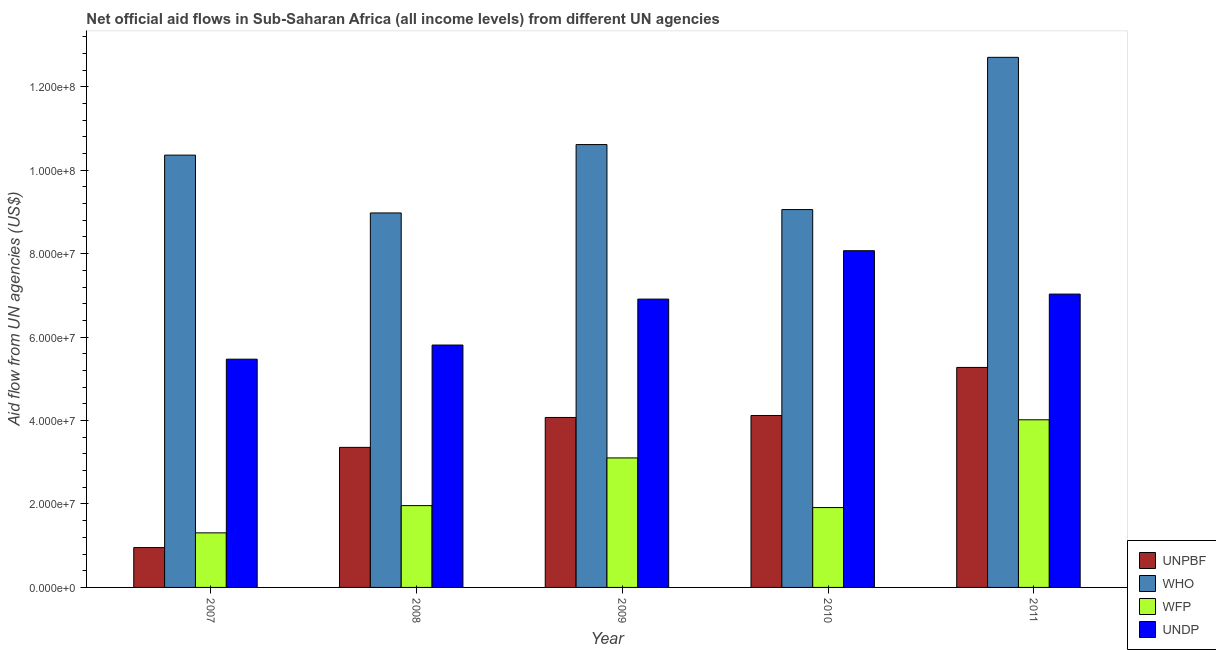How many bars are there on the 5th tick from the left?
Your answer should be compact. 4. How many bars are there on the 2nd tick from the right?
Give a very brief answer. 4. In how many cases, is the number of bars for a given year not equal to the number of legend labels?
Your answer should be compact. 0. What is the amount of aid given by wfp in 2008?
Your answer should be compact. 1.96e+07. Across all years, what is the maximum amount of aid given by wfp?
Provide a short and direct response. 4.02e+07. Across all years, what is the minimum amount of aid given by wfp?
Offer a terse response. 1.31e+07. In which year was the amount of aid given by who minimum?
Provide a succinct answer. 2008. What is the total amount of aid given by who in the graph?
Ensure brevity in your answer.  5.17e+08. What is the difference between the amount of aid given by who in 2007 and that in 2011?
Your answer should be very brief. -2.34e+07. What is the difference between the amount of aid given by unpbf in 2010 and the amount of aid given by wfp in 2007?
Your answer should be compact. 3.17e+07. What is the average amount of aid given by who per year?
Your response must be concise. 1.03e+08. In the year 2011, what is the difference between the amount of aid given by wfp and amount of aid given by who?
Your answer should be very brief. 0. In how many years, is the amount of aid given by wfp greater than 56000000 US$?
Ensure brevity in your answer.  0. What is the ratio of the amount of aid given by unpbf in 2007 to that in 2011?
Your answer should be very brief. 0.18. Is the amount of aid given by who in 2008 less than that in 2009?
Your answer should be compact. Yes. Is the difference between the amount of aid given by wfp in 2007 and 2008 greater than the difference between the amount of aid given by unpbf in 2007 and 2008?
Your answer should be compact. No. What is the difference between the highest and the second highest amount of aid given by wfp?
Offer a terse response. 9.14e+06. What is the difference between the highest and the lowest amount of aid given by unpbf?
Your answer should be very brief. 4.32e+07. What does the 1st bar from the left in 2007 represents?
Offer a very short reply. UNPBF. What does the 2nd bar from the right in 2007 represents?
Provide a succinct answer. WFP. Is it the case that in every year, the sum of the amount of aid given by unpbf and amount of aid given by who is greater than the amount of aid given by wfp?
Your response must be concise. Yes. How many bars are there?
Provide a short and direct response. 20. What is the difference between two consecutive major ticks on the Y-axis?
Give a very brief answer. 2.00e+07. Are the values on the major ticks of Y-axis written in scientific E-notation?
Your answer should be very brief. Yes. Does the graph contain grids?
Offer a terse response. No. How many legend labels are there?
Your answer should be very brief. 4. What is the title of the graph?
Give a very brief answer. Net official aid flows in Sub-Saharan Africa (all income levels) from different UN agencies. Does "Agriculture" appear as one of the legend labels in the graph?
Make the answer very short. No. What is the label or title of the Y-axis?
Provide a succinct answer. Aid flow from UN agencies (US$). What is the Aid flow from UN agencies (US$) of UNPBF in 2007?
Keep it short and to the point. 9.55e+06. What is the Aid flow from UN agencies (US$) of WHO in 2007?
Give a very brief answer. 1.04e+08. What is the Aid flow from UN agencies (US$) of WFP in 2007?
Your answer should be very brief. 1.31e+07. What is the Aid flow from UN agencies (US$) of UNDP in 2007?
Offer a terse response. 5.47e+07. What is the Aid flow from UN agencies (US$) in UNPBF in 2008?
Your answer should be compact. 3.36e+07. What is the Aid flow from UN agencies (US$) of WHO in 2008?
Offer a very short reply. 8.98e+07. What is the Aid flow from UN agencies (US$) in WFP in 2008?
Your answer should be very brief. 1.96e+07. What is the Aid flow from UN agencies (US$) of UNDP in 2008?
Your answer should be compact. 5.81e+07. What is the Aid flow from UN agencies (US$) of UNPBF in 2009?
Ensure brevity in your answer.  4.07e+07. What is the Aid flow from UN agencies (US$) in WHO in 2009?
Your response must be concise. 1.06e+08. What is the Aid flow from UN agencies (US$) in WFP in 2009?
Offer a very short reply. 3.10e+07. What is the Aid flow from UN agencies (US$) of UNDP in 2009?
Your answer should be very brief. 6.91e+07. What is the Aid flow from UN agencies (US$) in UNPBF in 2010?
Your answer should be compact. 4.12e+07. What is the Aid flow from UN agencies (US$) in WHO in 2010?
Your answer should be very brief. 9.06e+07. What is the Aid flow from UN agencies (US$) of WFP in 2010?
Your answer should be compact. 1.91e+07. What is the Aid flow from UN agencies (US$) of UNDP in 2010?
Give a very brief answer. 8.07e+07. What is the Aid flow from UN agencies (US$) in UNPBF in 2011?
Offer a terse response. 5.27e+07. What is the Aid flow from UN agencies (US$) of WHO in 2011?
Provide a short and direct response. 1.27e+08. What is the Aid flow from UN agencies (US$) in WFP in 2011?
Provide a short and direct response. 4.02e+07. What is the Aid flow from UN agencies (US$) in UNDP in 2011?
Offer a terse response. 7.03e+07. Across all years, what is the maximum Aid flow from UN agencies (US$) in UNPBF?
Give a very brief answer. 5.27e+07. Across all years, what is the maximum Aid flow from UN agencies (US$) in WHO?
Provide a succinct answer. 1.27e+08. Across all years, what is the maximum Aid flow from UN agencies (US$) in WFP?
Provide a short and direct response. 4.02e+07. Across all years, what is the maximum Aid flow from UN agencies (US$) of UNDP?
Your answer should be very brief. 8.07e+07. Across all years, what is the minimum Aid flow from UN agencies (US$) in UNPBF?
Keep it short and to the point. 9.55e+06. Across all years, what is the minimum Aid flow from UN agencies (US$) in WHO?
Your answer should be very brief. 8.98e+07. Across all years, what is the minimum Aid flow from UN agencies (US$) of WFP?
Offer a very short reply. 1.31e+07. Across all years, what is the minimum Aid flow from UN agencies (US$) of UNDP?
Keep it short and to the point. 5.47e+07. What is the total Aid flow from UN agencies (US$) of UNPBF in the graph?
Provide a short and direct response. 1.78e+08. What is the total Aid flow from UN agencies (US$) in WHO in the graph?
Provide a succinct answer. 5.17e+08. What is the total Aid flow from UN agencies (US$) in WFP in the graph?
Your answer should be very brief. 1.23e+08. What is the total Aid flow from UN agencies (US$) in UNDP in the graph?
Provide a succinct answer. 3.33e+08. What is the difference between the Aid flow from UN agencies (US$) of UNPBF in 2007 and that in 2008?
Offer a very short reply. -2.40e+07. What is the difference between the Aid flow from UN agencies (US$) of WHO in 2007 and that in 2008?
Offer a terse response. 1.39e+07. What is the difference between the Aid flow from UN agencies (US$) of WFP in 2007 and that in 2008?
Offer a very short reply. -6.53e+06. What is the difference between the Aid flow from UN agencies (US$) in UNDP in 2007 and that in 2008?
Give a very brief answer. -3.39e+06. What is the difference between the Aid flow from UN agencies (US$) of UNPBF in 2007 and that in 2009?
Provide a succinct answer. -3.12e+07. What is the difference between the Aid flow from UN agencies (US$) of WHO in 2007 and that in 2009?
Your response must be concise. -2.53e+06. What is the difference between the Aid flow from UN agencies (US$) of WFP in 2007 and that in 2009?
Your response must be concise. -1.80e+07. What is the difference between the Aid flow from UN agencies (US$) of UNDP in 2007 and that in 2009?
Your response must be concise. -1.44e+07. What is the difference between the Aid flow from UN agencies (US$) in UNPBF in 2007 and that in 2010?
Your answer should be compact. -3.17e+07. What is the difference between the Aid flow from UN agencies (US$) of WHO in 2007 and that in 2010?
Keep it short and to the point. 1.30e+07. What is the difference between the Aid flow from UN agencies (US$) in WFP in 2007 and that in 2010?
Offer a very short reply. -6.06e+06. What is the difference between the Aid flow from UN agencies (US$) of UNDP in 2007 and that in 2010?
Ensure brevity in your answer.  -2.60e+07. What is the difference between the Aid flow from UN agencies (US$) in UNPBF in 2007 and that in 2011?
Offer a very short reply. -4.32e+07. What is the difference between the Aid flow from UN agencies (US$) in WHO in 2007 and that in 2011?
Keep it short and to the point. -2.34e+07. What is the difference between the Aid flow from UN agencies (US$) in WFP in 2007 and that in 2011?
Make the answer very short. -2.71e+07. What is the difference between the Aid flow from UN agencies (US$) of UNDP in 2007 and that in 2011?
Your answer should be very brief. -1.56e+07. What is the difference between the Aid flow from UN agencies (US$) of UNPBF in 2008 and that in 2009?
Offer a very short reply. -7.17e+06. What is the difference between the Aid flow from UN agencies (US$) of WHO in 2008 and that in 2009?
Ensure brevity in your answer.  -1.64e+07. What is the difference between the Aid flow from UN agencies (US$) in WFP in 2008 and that in 2009?
Keep it short and to the point. -1.14e+07. What is the difference between the Aid flow from UN agencies (US$) of UNDP in 2008 and that in 2009?
Your answer should be very brief. -1.10e+07. What is the difference between the Aid flow from UN agencies (US$) of UNPBF in 2008 and that in 2010?
Offer a terse response. -7.64e+06. What is the difference between the Aid flow from UN agencies (US$) of WHO in 2008 and that in 2010?
Make the answer very short. -8.10e+05. What is the difference between the Aid flow from UN agencies (US$) in UNDP in 2008 and that in 2010?
Your response must be concise. -2.26e+07. What is the difference between the Aid flow from UN agencies (US$) in UNPBF in 2008 and that in 2011?
Provide a succinct answer. -1.92e+07. What is the difference between the Aid flow from UN agencies (US$) in WHO in 2008 and that in 2011?
Ensure brevity in your answer.  -3.73e+07. What is the difference between the Aid flow from UN agencies (US$) of WFP in 2008 and that in 2011?
Give a very brief answer. -2.06e+07. What is the difference between the Aid flow from UN agencies (US$) of UNDP in 2008 and that in 2011?
Offer a terse response. -1.22e+07. What is the difference between the Aid flow from UN agencies (US$) in UNPBF in 2009 and that in 2010?
Your answer should be very brief. -4.70e+05. What is the difference between the Aid flow from UN agencies (US$) of WHO in 2009 and that in 2010?
Make the answer very short. 1.56e+07. What is the difference between the Aid flow from UN agencies (US$) in WFP in 2009 and that in 2010?
Your answer should be compact. 1.19e+07. What is the difference between the Aid flow from UN agencies (US$) of UNDP in 2009 and that in 2010?
Your answer should be compact. -1.16e+07. What is the difference between the Aid flow from UN agencies (US$) of UNPBF in 2009 and that in 2011?
Make the answer very short. -1.20e+07. What is the difference between the Aid flow from UN agencies (US$) of WHO in 2009 and that in 2011?
Your response must be concise. -2.09e+07. What is the difference between the Aid flow from UN agencies (US$) of WFP in 2009 and that in 2011?
Provide a succinct answer. -9.14e+06. What is the difference between the Aid flow from UN agencies (US$) of UNDP in 2009 and that in 2011?
Ensure brevity in your answer.  -1.20e+06. What is the difference between the Aid flow from UN agencies (US$) of UNPBF in 2010 and that in 2011?
Make the answer very short. -1.15e+07. What is the difference between the Aid flow from UN agencies (US$) of WHO in 2010 and that in 2011?
Offer a terse response. -3.65e+07. What is the difference between the Aid flow from UN agencies (US$) in WFP in 2010 and that in 2011?
Give a very brief answer. -2.10e+07. What is the difference between the Aid flow from UN agencies (US$) in UNDP in 2010 and that in 2011?
Your response must be concise. 1.04e+07. What is the difference between the Aid flow from UN agencies (US$) of UNPBF in 2007 and the Aid flow from UN agencies (US$) of WHO in 2008?
Provide a succinct answer. -8.02e+07. What is the difference between the Aid flow from UN agencies (US$) of UNPBF in 2007 and the Aid flow from UN agencies (US$) of WFP in 2008?
Provide a short and direct response. -1.01e+07. What is the difference between the Aid flow from UN agencies (US$) of UNPBF in 2007 and the Aid flow from UN agencies (US$) of UNDP in 2008?
Make the answer very short. -4.86e+07. What is the difference between the Aid flow from UN agencies (US$) in WHO in 2007 and the Aid flow from UN agencies (US$) in WFP in 2008?
Keep it short and to the point. 8.40e+07. What is the difference between the Aid flow from UN agencies (US$) of WHO in 2007 and the Aid flow from UN agencies (US$) of UNDP in 2008?
Provide a short and direct response. 4.55e+07. What is the difference between the Aid flow from UN agencies (US$) of WFP in 2007 and the Aid flow from UN agencies (US$) of UNDP in 2008?
Ensure brevity in your answer.  -4.50e+07. What is the difference between the Aid flow from UN agencies (US$) in UNPBF in 2007 and the Aid flow from UN agencies (US$) in WHO in 2009?
Your answer should be compact. -9.66e+07. What is the difference between the Aid flow from UN agencies (US$) in UNPBF in 2007 and the Aid flow from UN agencies (US$) in WFP in 2009?
Make the answer very short. -2.15e+07. What is the difference between the Aid flow from UN agencies (US$) in UNPBF in 2007 and the Aid flow from UN agencies (US$) in UNDP in 2009?
Ensure brevity in your answer.  -5.96e+07. What is the difference between the Aid flow from UN agencies (US$) in WHO in 2007 and the Aid flow from UN agencies (US$) in WFP in 2009?
Ensure brevity in your answer.  7.26e+07. What is the difference between the Aid flow from UN agencies (US$) of WHO in 2007 and the Aid flow from UN agencies (US$) of UNDP in 2009?
Keep it short and to the point. 3.45e+07. What is the difference between the Aid flow from UN agencies (US$) in WFP in 2007 and the Aid flow from UN agencies (US$) in UNDP in 2009?
Offer a very short reply. -5.60e+07. What is the difference between the Aid flow from UN agencies (US$) in UNPBF in 2007 and the Aid flow from UN agencies (US$) in WHO in 2010?
Provide a succinct answer. -8.10e+07. What is the difference between the Aid flow from UN agencies (US$) of UNPBF in 2007 and the Aid flow from UN agencies (US$) of WFP in 2010?
Offer a very short reply. -9.59e+06. What is the difference between the Aid flow from UN agencies (US$) of UNPBF in 2007 and the Aid flow from UN agencies (US$) of UNDP in 2010?
Give a very brief answer. -7.12e+07. What is the difference between the Aid flow from UN agencies (US$) in WHO in 2007 and the Aid flow from UN agencies (US$) in WFP in 2010?
Offer a terse response. 8.45e+07. What is the difference between the Aid flow from UN agencies (US$) of WHO in 2007 and the Aid flow from UN agencies (US$) of UNDP in 2010?
Provide a short and direct response. 2.29e+07. What is the difference between the Aid flow from UN agencies (US$) of WFP in 2007 and the Aid flow from UN agencies (US$) of UNDP in 2010?
Ensure brevity in your answer.  -6.76e+07. What is the difference between the Aid flow from UN agencies (US$) in UNPBF in 2007 and the Aid flow from UN agencies (US$) in WHO in 2011?
Provide a short and direct response. -1.18e+08. What is the difference between the Aid flow from UN agencies (US$) of UNPBF in 2007 and the Aid flow from UN agencies (US$) of WFP in 2011?
Offer a very short reply. -3.06e+07. What is the difference between the Aid flow from UN agencies (US$) in UNPBF in 2007 and the Aid flow from UN agencies (US$) in UNDP in 2011?
Provide a succinct answer. -6.08e+07. What is the difference between the Aid flow from UN agencies (US$) of WHO in 2007 and the Aid flow from UN agencies (US$) of WFP in 2011?
Ensure brevity in your answer.  6.34e+07. What is the difference between the Aid flow from UN agencies (US$) in WHO in 2007 and the Aid flow from UN agencies (US$) in UNDP in 2011?
Your answer should be very brief. 3.33e+07. What is the difference between the Aid flow from UN agencies (US$) in WFP in 2007 and the Aid flow from UN agencies (US$) in UNDP in 2011?
Ensure brevity in your answer.  -5.72e+07. What is the difference between the Aid flow from UN agencies (US$) in UNPBF in 2008 and the Aid flow from UN agencies (US$) in WHO in 2009?
Your answer should be compact. -7.26e+07. What is the difference between the Aid flow from UN agencies (US$) of UNPBF in 2008 and the Aid flow from UN agencies (US$) of WFP in 2009?
Your answer should be very brief. 2.53e+06. What is the difference between the Aid flow from UN agencies (US$) of UNPBF in 2008 and the Aid flow from UN agencies (US$) of UNDP in 2009?
Make the answer very short. -3.55e+07. What is the difference between the Aid flow from UN agencies (US$) in WHO in 2008 and the Aid flow from UN agencies (US$) in WFP in 2009?
Give a very brief answer. 5.87e+07. What is the difference between the Aid flow from UN agencies (US$) of WHO in 2008 and the Aid flow from UN agencies (US$) of UNDP in 2009?
Keep it short and to the point. 2.06e+07. What is the difference between the Aid flow from UN agencies (US$) of WFP in 2008 and the Aid flow from UN agencies (US$) of UNDP in 2009?
Provide a short and direct response. -4.95e+07. What is the difference between the Aid flow from UN agencies (US$) in UNPBF in 2008 and the Aid flow from UN agencies (US$) in WHO in 2010?
Provide a succinct answer. -5.70e+07. What is the difference between the Aid flow from UN agencies (US$) of UNPBF in 2008 and the Aid flow from UN agencies (US$) of WFP in 2010?
Your response must be concise. 1.44e+07. What is the difference between the Aid flow from UN agencies (US$) in UNPBF in 2008 and the Aid flow from UN agencies (US$) in UNDP in 2010?
Provide a succinct answer. -4.71e+07. What is the difference between the Aid flow from UN agencies (US$) in WHO in 2008 and the Aid flow from UN agencies (US$) in WFP in 2010?
Ensure brevity in your answer.  7.06e+07. What is the difference between the Aid flow from UN agencies (US$) in WHO in 2008 and the Aid flow from UN agencies (US$) in UNDP in 2010?
Offer a terse response. 9.05e+06. What is the difference between the Aid flow from UN agencies (US$) in WFP in 2008 and the Aid flow from UN agencies (US$) in UNDP in 2010?
Ensure brevity in your answer.  -6.11e+07. What is the difference between the Aid flow from UN agencies (US$) in UNPBF in 2008 and the Aid flow from UN agencies (US$) in WHO in 2011?
Keep it short and to the point. -9.35e+07. What is the difference between the Aid flow from UN agencies (US$) of UNPBF in 2008 and the Aid flow from UN agencies (US$) of WFP in 2011?
Keep it short and to the point. -6.61e+06. What is the difference between the Aid flow from UN agencies (US$) of UNPBF in 2008 and the Aid flow from UN agencies (US$) of UNDP in 2011?
Provide a short and direct response. -3.67e+07. What is the difference between the Aid flow from UN agencies (US$) of WHO in 2008 and the Aid flow from UN agencies (US$) of WFP in 2011?
Offer a very short reply. 4.96e+07. What is the difference between the Aid flow from UN agencies (US$) of WHO in 2008 and the Aid flow from UN agencies (US$) of UNDP in 2011?
Provide a succinct answer. 1.94e+07. What is the difference between the Aid flow from UN agencies (US$) of WFP in 2008 and the Aid flow from UN agencies (US$) of UNDP in 2011?
Offer a terse response. -5.07e+07. What is the difference between the Aid flow from UN agencies (US$) of UNPBF in 2009 and the Aid flow from UN agencies (US$) of WHO in 2010?
Give a very brief answer. -4.98e+07. What is the difference between the Aid flow from UN agencies (US$) of UNPBF in 2009 and the Aid flow from UN agencies (US$) of WFP in 2010?
Offer a very short reply. 2.16e+07. What is the difference between the Aid flow from UN agencies (US$) in UNPBF in 2009 and the Aid flow from UN agencies (US$) in UNDP in 2010?
Provide a succinct answer. -4.00e+07. What is the difference between the Aid flow from UN agencies (US$) of WHO in 2009 and the Aid flow from UN agencies (US$) of WFP in 2010?
Ensure brevity in your answer.  8.70e+07. What is the difference between the Aid flow from UN agencies (US$) in WHO in 2009 and the Aid flow from UN agencies (US$) in UNDP in 2010?
Give a very brief answer. 2.54e+07. What is the difference between the Aid flow from UN agencies (US$) in WFP in 2009 and the Aid flow from UN agencies (US$) in UNDP in 2010?
Ensure brevity in your answer.  -4.97e+07. What is the difference between the Aid flow from UN agencies (US$) in UNPBF in 2009 and the Aid flow from UN agencies (US$) in WHO in 2011?
Give a very brief answer. -8.63e+07. What is the difference between the Aid flow from UN agencies (US$) of UNPBF in 2009 and the Aid flow from UN agencies (US$) of WFP in 2011?
Your answer should be compact. 5.60e+05. What is the difference between the Aid flow from UN agencies (US$) in UNPBF in 2009 and the Aid flow from UN agencies (US$) in UNDP in 2011?
Give a very brief answer. -2.96e+07. What is the difference between the Aid flow from UN agencies (US$) of WHO in 2009 and the Aid flow from UN agencies (US$) of WFP in 2011?
Ensure brevity in your answer.  6.60e+07. What is the difference between the Aid flow from UN agencies (US$) in WHO in 2009 and the Aid flow from UN agencies (US$) in UNDP in 2011?
Offer a very short reply. 3.58e+07. What is the difference between the Aid flow from UN agencies (US$) of WFP in 2009 and the Aid flow from UN agencies (US$) of UNDP in 2011?
Your response must be concise. -3.93e+07. What is the difference between the Aid flow from UN agencies (US$) in UNPBF in 2010 and the Aid flow from UN agencies (US$) in WHO in 2011?
Ensure brevity in your answer.  -8.58e+07. What is the difference between the Aid flow from UN agencies (US$) of UNPBF in 2010 and the Aid flow from UN agencies (US$) of WFP in 2011?
Your answer should be very brief. 1.03e+06. What is the difference between the Aid flow from UN agencies (US$) of UNPBF in 2010 and the Aid flow from UN agencies (US$) of UNDP in 2011?
Provide a succinct answer. -2.91e+07. What is the difference between the Aid flow from UN agencies (US$) in WHO in 2010 and the Aid flow from UN agencies (US$) in WFP in 2011?
Keep it short and to the point. 5.04e+07. What is the difference between the Aid flow from UN agencies (US$) in WHO in 2010 and the Aid flow from UN agencies (US$) in UNDP in 2011?
Provide a succinct answer. 2.03e+07. What is the difference between the Aid flow from UN agencies (US$) in WFP in 2010 and the Aid flow from UN agencies (US$) in UNDP in 2011?
Your response must be concise. -5.12e+07. What is the average Aid flow from UN agencies (US$) of UNPBF per year?
Keep it short and to the point. 3.56e+07. What is the average Aid flow from UN agencies (US$) in WHO per year?
Offer a terse response. 1.03e+08. What is the average Aid flow from UN agencies (US$) of WFP per year?
Offer a terse response. 2.46e+07. What is the average Aid flow from UN agencies (US$) of UNDP per year?
Offer a very short reply. 6.66e+07. In the year 2007, what is the difference between the Aid flow from UN agencies (US$) in UNPBF and Aid flow from UN agencies (US$) in WHO?
Your answer should be very brief. -9.41e+07. In the year 2007, what is the difference between the Aid flow from UN agencies (US$) in UNPBF and Aid flow from UN agencies (US$) in WFP?
Keep it short and to the point. -3.53e+06. In the year 2007, what is the difference between the Aid flow from UN agencies (US$) in UNPBF and Aid flow from UN agencies (US$) in UNDP?
Provide a short and direct response. -4.52e+07. In the year 2007, what is the difference between the Aid flow from UN agencies (US$) of WHO and Aid flow from UN agencies (US$) of WFP?
Give a very brief answer. 9.05e+07. In the year 2007, what is the difference between the Aid flow from UN agencies (US$) in WHO and Aid flow from UN agencies (US$) in UNDP?
Provide a succinct answer. 4.89e+07. In the year 2007, what is the difference between the Aid flow from UN agencies (US$) in WFP and Aid flow from UN agencies (US$) in UNDP?
Offer a very short reply. -4.16e+07. In the year 2008, what is the difference between the Aid flow from UN agencies (US$) in UNPBF and Aid flow from UN agencies (US$) in WHO?
Ensure brevity in your answer.  -5.62e+07. In the year 2008, what is the difference between the Aid flow from UN agencies (US$) in UNPBF and Aid flow from UN agencies (US$) in WFP?
Keep it short and to the point. 1.40e+07. In the year 2008, what is the difference between the Aid flow from UN agencies (US$) of UNPBF and Aid flow from UN agencies (US$) of UNDP?
Give a very brief answer. -2.45e+07. In the year 2008, what is the difference between the Aid flow from UN agencies (US$) in WHO and Aid flow from UN agencies (US$) in WFP?
Keep it short and to the point. 7.02e+07. In the year 2008, what is the difference between the Aid flow from UN agencies (US$) in WHO and Aid flow from UN agencies (US$) in UNDP?
Provide a short and direct response. 3.17e+07. In the year 2008, what is the difference between the Aid flow from UN agencies (US$) of WFP and Aid flow from UN agencies (US$) of UNDP?
Your response must be concise. -3.85e+07. In the year 2009, what is the difference between the Aid flow from UN agencies (US$) in UNPBF and Aid flow from UN agencies (US$) in WHO?
Give a very brief answer. -6.54e+07. In the year 2009, what is the difference between the Aid flow from UN agencies (US$) of UNPBF and Aid flow from UN agencies (US$) of WFP?
Offer a terse response. 9.70e+06. In the year 2009, what is the difference between the Aid flow from UN agencies (US$) of UNPBF and Aid flow from UN agencies (US$) of UNDP?
Your response must be concise. -2.84e+07. In the year 2009, what is the difference between the Aid flow from UN agencies (US$) of WHO and Aid flow from UN agencies (US$) of WFP?
Offer a very short reply. 7.51e+07. In the year 2009, what is the difference between the Aid flow from UN agencies (US$) of WHO and Aid flow from UN agencies (US$) of UNDP?
Provide a short and direct response. 3.70e+07. In the year 2009, what is the difference between the Aid flow from UN agencies (US$) in WFP and Aid flow from UN agencies (US$) in UNDP?
Ensure brevity in your answer.  -3.81e+07. In the year 2010, what is the difference between the Aid flow from UN agencies (US$) in UNPBF and Aid flow from UN agencies (US$) in WHO?
Ensure brevity in your answer.  -4.94e+07. In the year 2010, what is the difference between the Aid flow from UN agencies (US$) in UNPBF and Aid flow from UN agencies (US$) in WFP?
Provide a short and direct response. 2.21e+07. In the year 2010, what is the difference between the Aid flow from UN agencies (US$) in UNPBF and Aid flow from UN agencies (US$) in UNDP?
Your answer should be compact. -3.95e+07. In the year 2010, what is the difference between the Aid flow from UN agencies (US$) in WHO and Aid flow from UN agencies (US$) in WFP?
Your response must be concise. 7.14e+07. In the year 2010, what is the difference between the Aid flow from UN agencies (US$) of WHO and Aid flow from UN agencies (US$) of UNDP?
Make the answer very short. 9.86e+06. In the year 2010, what is the difference between the Aid flow from UN agencies (US$) of WFP and Aid flow from UN agencies (US$) of UNDP?
Offer a terse response. -6.16e+07. In the year 2011, what is the difference between the Aid flow from UN agencies (US$) in UNPBF and Aid flow from UN agencies (US$) in WHO?
Ensure brevity in your answer.  -7.43e+07. In the year 2011, what is the difference between the Aid flow from UN agencies (US$) of UNPBF and Aid flow from UN agencies (US$) of WFP?
Provide a succinct answer. 1.26e+07. In the year 2011, what is the difference between the Aid flow from UN agencies (US$) of UNPBF and Aid flow from UN agencies (US$) of UNDP?
Offer a very short reply. -1.76e+07. In the year 2011, what is the difference between the Aid flow from UN agencies (US$) in WHO and Aid flow from UN agencies (US$) in WFP?
Offer a terse response. 8.69e+07. In the year 2011, what is the difference between the Aid flow from UN agencies (US$) in WHO and Aid flow from UN agencies (US$) in UNDP?
Make the answer very short. 5.68e+07. In the year 2011, what is the difference between the Aid flow from UN agencies (US$) of WFP and Aid flow from UN agencies (US$) of UNDP?
Your answer should be compact. -3.01e+07. What is the ratio of the Aid flow from UN agencies (US$) in UNPBF in 2007 to that in 2008?
Offer a very short reply. 0.28. What is the ratio of the Aid flow from UN agencies (US$) of WHO in 2007 to that in 2008?
Offer a very short reply. 1.15. What is the ratio of the Aid flow from UN agencies (US$) in WFP in 2007 to that in 2008?
Your response must be concise. 0.67. What is the ratio of the Aid flow from UN agencies (US$) of UNDP in 2007 to that in 2008?
Offer a very short reply. 0.94. What is the ratio of the Aid flow from UN agencies (US$) of UNPBF in 2007 to that in 2009?
Your answer should be compact. 0.23. What is the ratio of the Aid flow from UN agencies (US$) in WHO in 2007 to that in 2009?
Ensure brevity in your answer.  0.98. What is the ratio of the Aid flow from UN agencies (US$) of WFP in 2007 to that in 2009?
Give a very brief answer. 0.42. What is the ratio of the Aid flow from UN agencies (US$) in UNDP in 2007 to that in 2009?
Give a very brief answer. 0.79. What is the ratio of the Aid flow from UN agencies (US$) of UNPBF in 2007 to that in 2010?
Your answer should be very brief. 0.23. What is the ratio of the Aid flow from UN agencies (US$) of WHO in 2007 to that in 2010?
Offer a terse response. 1.14. What is the ratio of the Aid flow from UN agencies (US$) of WFP in 2007 to that in 2010?
Your answer should be compact. 0.68. What is the ratio of the Aid flow from UN agencies (US$) of UNDP in 2007 to that in 2010?
Provide a succinct answer. 0.68. What is the ratio of the Aid flow from UN agencies (US$) in UNPBF in 2007 to that in 2011?
Your response must be concise. 0.18. What is the ratio of the Aid flow from UN agencies (US$) of WHO in 2007 to that in 2011?
Keep it short and to the point. 0.82. What is the ratio of the Aid flow from UN agencies (US$) of WFP in 2007 to that in 2011?
Make the answer very short. 0.33. What is the ratio of the Aid flow from UN agencies (US$) of UNDP in 2007 to that in 2011?
Give a very brief answer. 0.78. What is the ratio of the Aid flow from UN agencies (US$) of UNPBF in 2008 to that in 2009?
Offer a terse response. 0.82. What is the ratio of the Aid flow from UN agencies (US$) of WHO in 2008 to that in 2009?
Your answer should be compact. 0.85. What is the ratio of the Aid flow from UN agencies (US$) in WFP in 2008 to that in 2009?
Offer a terse response. 0.63. What is the ratio of the Aid flow from UN agencies (US$) in UNDP in 2008 to that in 2009?
Provide a short and direct response. 0.84. What is the ratio of the Aid flow from UN agencies (US$) of UNPBF in 2008 to that in 2010?
Provide a succinct answer. 0.81. What is the ratio of the Aid flow from UN agencies (US$) of WHO in 2008 to that in 2010?
Keep it short and to the point. 0.99. What is the ratio of the Aid flow from UN agencies (US$) in WFP in 2008 to that in 2010?
Give a very brief answer. 1.02. What is the ratio of the Aid flow from UN agencies (US$) in UNDP in 2008 to that in 2010?
Make the answer very short. 0.72. What is the ratio of the Aid flow from UN agencies (US$) of UNPBF in 2008 to that in 2011?
Your answer should be very brief. 0.64. What is the ratio of the Aid flow from UN agencies (US$) in WHO in 2008 to that in 2011?
Make the answer very short. 0.71. What is the ratio of the Aid flow from UN agencies (US$) in WFP in 2008 to that in 2011?
Your answer should be very brief. 0.49. What is the ratio of the Aid flow from UN agencies (US$) of UNDP in 2008 to that in 2011?
Your answer should be compact. 0.83. What is the ratio of the Aid flow from UN agencies (US$) of UNPBF in 2009 to that in 2010?
Your answer should be very brief. 0.99. What is the ratio of the Aid flow from UN agencies (US$) in WHO in 2009 to that in 2010?
Provide a succinct answer. 1.17. What is the ratio of the Aid flow from UN agencies (US$) of WFP in 2009 to that in 2010?
Provide a short and direct response. 1.62. What is the ratio of the Aid flow from UN agencies (US$) in UNDP in 2009 to that in 2010?
Provide a succinct answer. 0.86. What is the ratio of the Aid flow from UN agencies (US$) in UNPBF in 2009 to that in 2011?
Offer a terse response. 0.77. What is the ratio of the Aid flow from UN agencies (US$) in WHO in 2009 to that in 2011?
Your answer should be very brief. 0.84. What is the ratio of the Aid flow from UN agencies (US$) of WFP in 2009 to that in 2011?
Your response must be concise. 0.77. What is the ratio of the Aid flow from UN agencies (US$) of UNDP in 2009 to that in 2011?
Make the answer very short. 0.98. What is the ratio of the Aid flow from UN agencies (US$) in UNPBF in 2010 to that in 2011?
Keep it short and to the point. 0.78. What is the ratio of the Aid flow from UN agencies (US$) of WHO in 2010 to that in 2011?
Your answer should be compact. 0.71. What is the ratio of the Aid flow from UN agencies (US$) in WFP in 2010 to that in 2011?
Offer a terse response. 0.48. What is the ratio of the Aid flow from UN agencies (US$) in UNDP in 2010 to that in 2011?
Provide a short and direct response. 1.15. What is the difference between the highest and the second highest Aid flow from UN agencies (US$) of UNPBF?
Offer a very short reply. 1.15e+07. What is the difference between the highest and the second highest Aid flow from UN agencies (US$) in WHO?
Give a very brief answer. 2.09e+07. What is the difference between the highest and the second highest Aid flow from UN agencies (US$) of WFP?
Your response must be concise. 9.14e+06. What is the difference between the highest and the second highest Aid flow from UN agencies (US$) of UNDP?
Your answer should be compact. 1.04e+07. What is the difference between the highest and the lowest Aid flow from UN agencies (US$) in UNPBF?
Offer a terse response. 4.32e+07. What is the difference between the highest and the lowest Aid flow from UN agencies (US$) in WHO?
Ensure brevity in your answer.  3.73e+07. What is the difference between the highest and the lowest Aid flow from UN agencies (US$) in WFP?
Offer a terse response. 2.71e+07. What is the difference between the highest and the lowest Aid flow from UN agencies (US$) in UNDP?
Ensure brevity in your answer.  2.60e+07. 